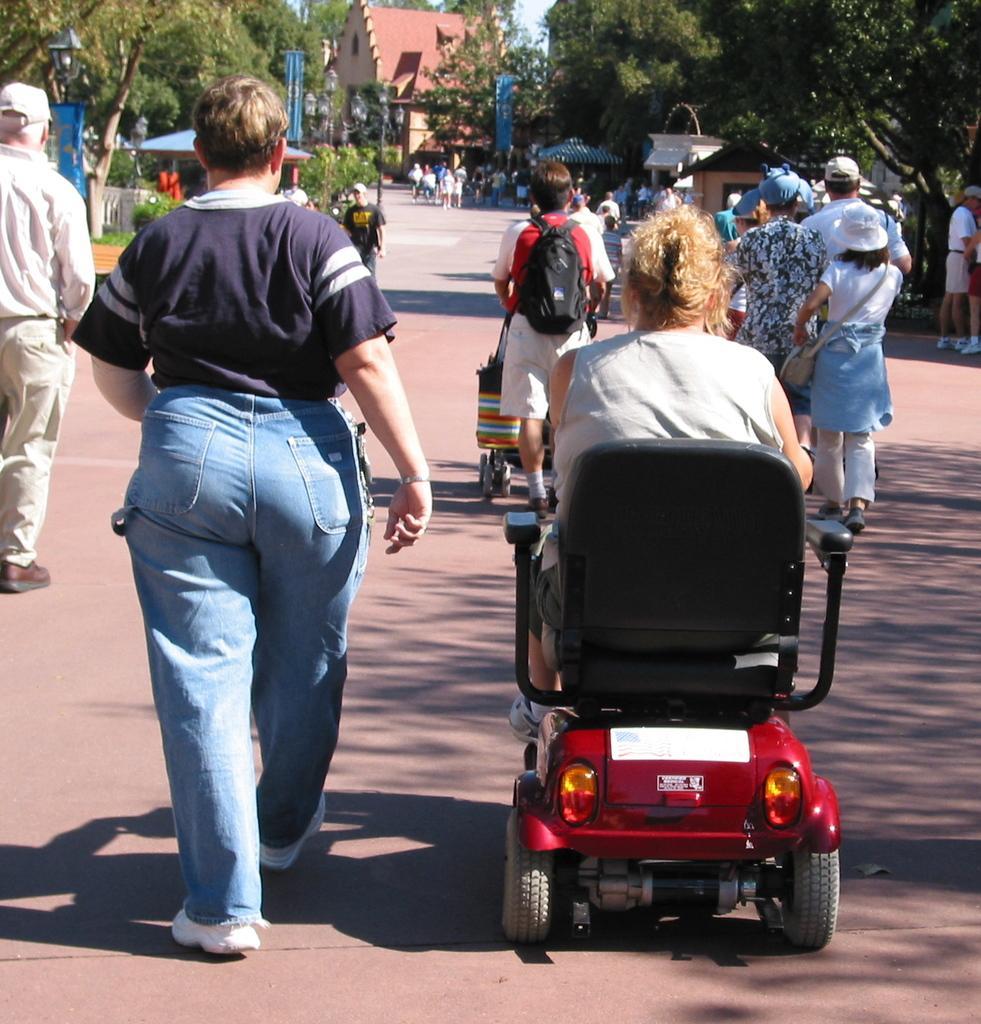In one or two sentences, can you explain what this image depicts? In this picture I can see a person on the vehicle, in the middle few people are walking on the road. There are trees on either side of this image, in the background I can see a building. 